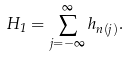Convert formula to latex. <formula><loc_0><loc_0><loc_500><loc_500>H _ { 1 } = \sum _ { j = - \infty } ^ { \infty } h _ { n ( j ) } .</formula> 